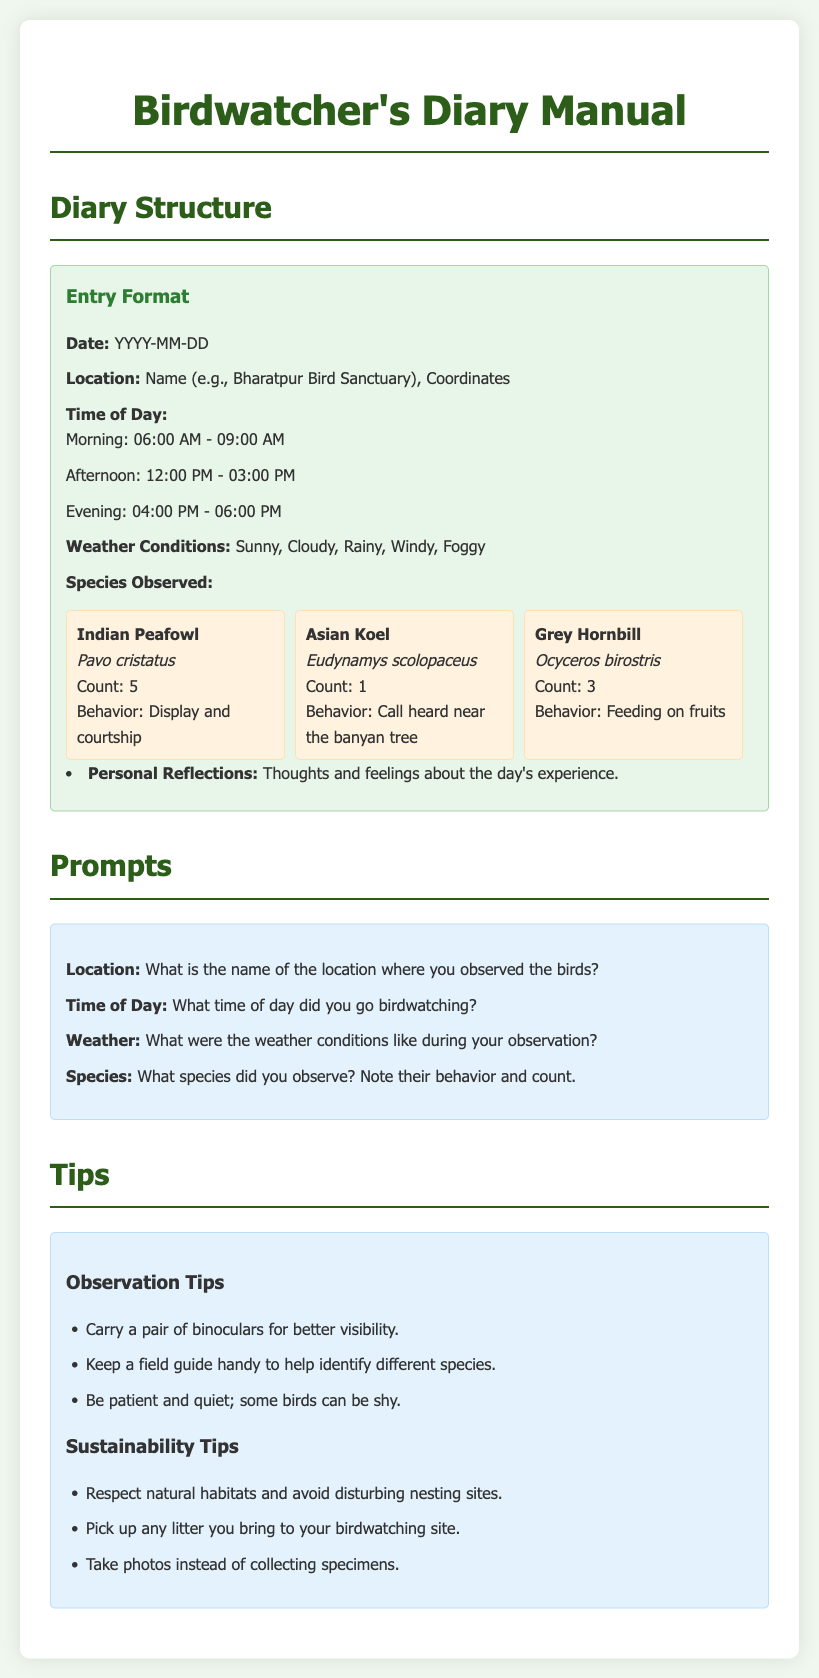What is the title of the manual? The title of the manual is indicated at the top of the document.
Answer: Birdwatcher's Diary Manual What time range is considered morning for birdwatching in the diary? The document specifies the morning time range in the entry format section.
Answer: 06:00 AM - 09:00 AM What species is observed with the behavior of displaying and courting? The species observed behavior is listed in the species section of the document.
Answer: Indian Peafowl How many observations of the Asian Koel were recorded? The count for the Asian Koel is provided in the species details.
Answer: 1 What are the weather conditions that can be noted in the diary? The manual lists possible weather conditions in the entry format section.
Answer: Sunny, Cloudy, Rainy, Windy, Foggy What are two observation tips mentioned in the document? The document includes a list of tips under observation advice.
Answer: Carry binoculars, Keep a field guide handy What is the personal reflection section for? The manual describes the purpose of this section in the diary entry format.
Answer: Thoughts and feelings about the day's experience Which location example is given for birdwatching? The location example is provided in the entry format section of the manual.
Answer: Bharatpur Bird Sanctuary 